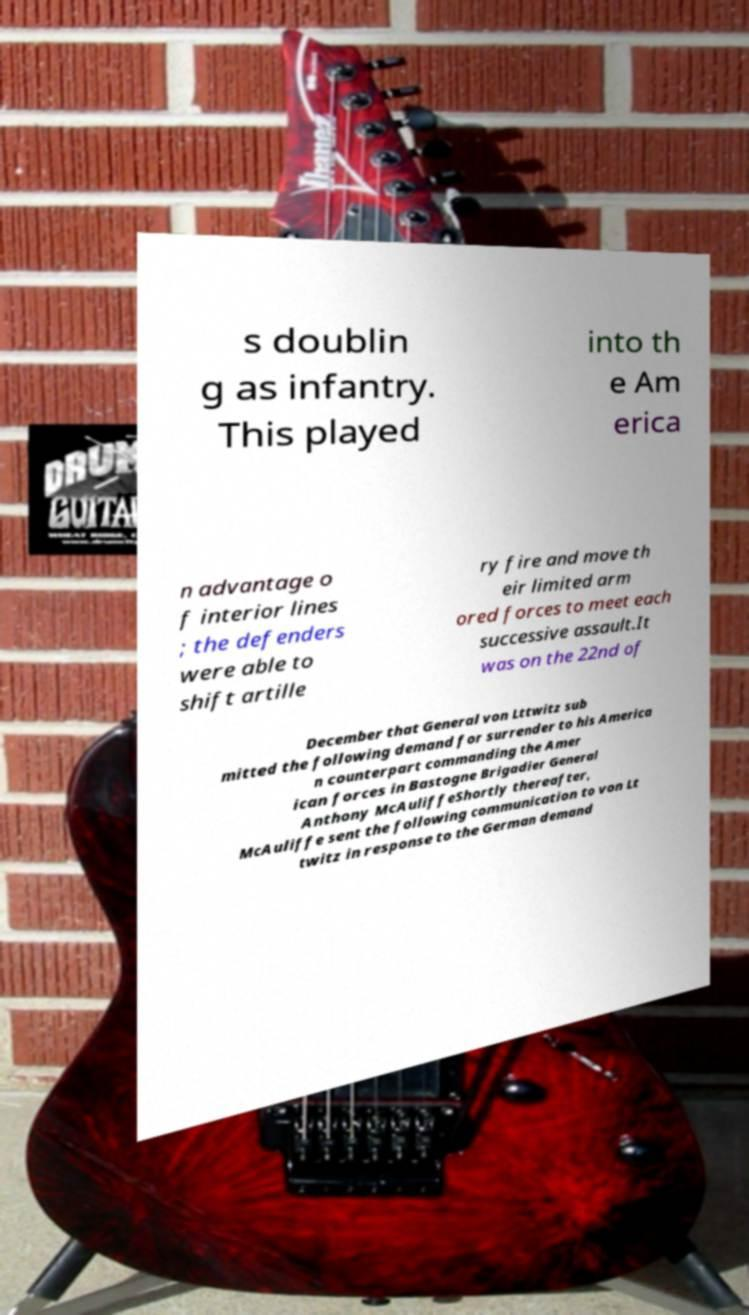What messages or text are displayed in this image? I need them in a readable, typed format. s doublin g as infantry. This played into th e Am erica n advantage o f interior lines ; the defenders were able to shift artille ry fire and move th eir limited arm ored forces to meet each successive assault.It was on the 22nd of December that General von Lttwitz sub mitted the following demand for surrender to his America n counterpart commanding the Amer ican forces in Bastogne Brigadier General Anthony McAuliffeShortly thereafter, McAuliffe sent the following communication to von Lt twitz in response to the German demand 